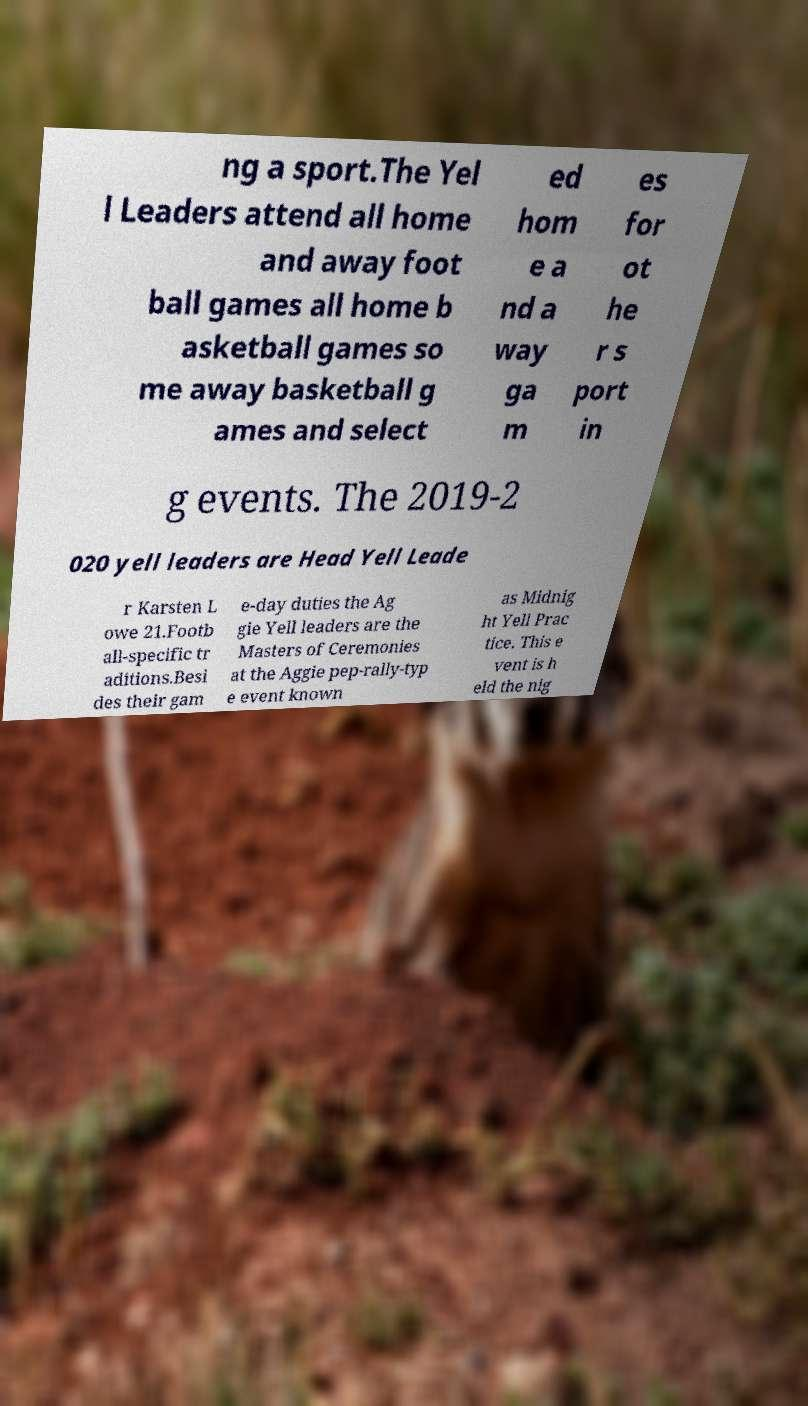Could you assist in decoding the text presented in this image and type it out clearly? ng a sport.The Yel l Leaders attend all home and away foot ball games all home b asketball games so me away basketball g ames and select ed hom e a nd a way ga m es for ot he r s port in g events. The 2019-2 020 yell leaders are Head Yell Leade r Karsten L owe 21.Footb all-specific tr aditions.Besi des their gam e-day duties the Ag gie Yell leaders are the Masters of Ceremonies at the Aggie pep-rally-typ e event known as Midnig ht Yell Prac tice. This e vent is h eld the nig 